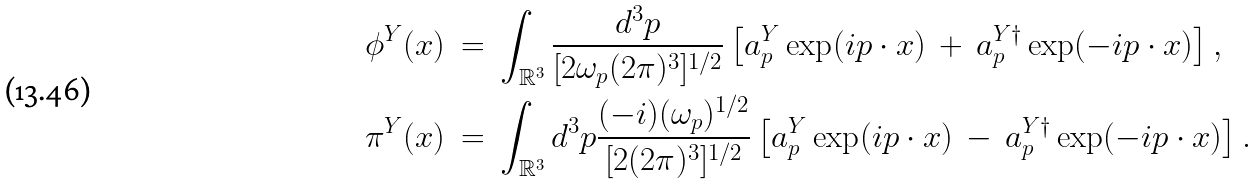Convert formula to latex. <formula><loc_0><loc_0><loc_500><loc_500>\phi ^ { Y } ( x ) \ & = \ \int _ { \mathbb { R } ^ { 3 } } \frac { d ^ { 3 } p } { [ 2 \omega _ { p } ( 2 \pi ) ^ { 3 } ] ^ { 1 / 2 } } \left [ a ^ { Y } _ { p } \exp ( i p \cdot x ) \, + \, a ^ { Y \dagger } _ { p } \exp ( - i p \cdot x ) \right ] , \\ \pi ^ { Y } ( x ) \ & = \ \int _ { \mathbb { R } ^ { 3 } } d ^ { 3 } p \frac { ( - i ) ( \omega _ { p } ) ^ { 1 / 2 } } { [ 2 ( 2 \pi ) ^ { 3 } ] ^ { 1 / 2 } } \left [ a ^ { Y } _ { p } \exp ( i p \cdot x ) \, - \, a ^ { Y \dagger } _ { p } \exp ( - i p \cdot x ) \right ] .</formula> 